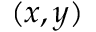Convert formula to latex. <formula><loc_0><loc_0><loc_500><loc_500>( x , y )</formula> 